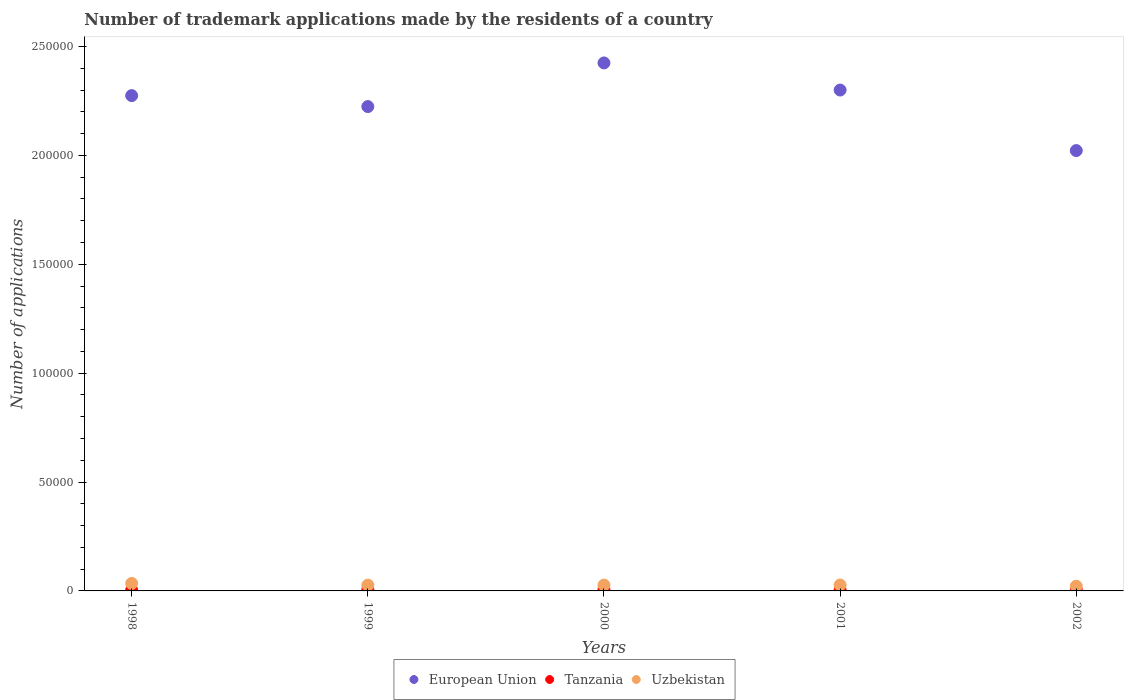How many different coloured dotlines are there?
Ensure brevity in your answer.  3. What is the number of trademark applications made by the residents in Uzbekistan in 1998?
Your response must be concise. 3441. Across all years, what is the maximum number of trademark applications made by the residents in European Union?
Offer a very short reply. 2.42e+05. Across all years, what is the minimum number of trademark applications made by the residents in Tanzania?
Provide a succinct answer. 412. In which year was the number of trademark applications made by the residents in Tanzania maximum?
Your answer should be very brief. 1999. In which year was the number of trademark applications made by the residents in Uzbekistan minimum?
Offer a very short reply. 2002. What is the total number of trademark applications made by the residents in Uzbekistan in the graph?
Ensure brevity in your answer.  1.37e+04. What is the difference between the number of trademark applications made by the residents in European Union in 2001 and that in 2002?
Your answer should be very brief. 2.78e+04. What is the difference between the number of trademark applications made by the residents in European Union in 2002 and the number of trademark applications made by the residents in Uzbekistan in 2000?
Your answer should be very brief. 2.00e+05. What is the average number of trademark applications made by the residents in Tanzania per year?
Offer a terse response. 505.2. In the year 1998, what is the difference between the number of trademark applications made by the residents in Tanzania and number of trademark applications made by the residents in Uzbekistan?
Provide a succinct answer. -3029. In how many years, is the number of trademark applications made by the residents in Uzbekistan greater than 210000?
Offer a very short reply. 0. What is the ratio of the number of trademark applications made by the residents in Uzbekistan in 1999 to that in 2001?
Offer a very short reply. 0.98. Is the difference between the number of trademark applications made by the residents in Tanzania in 1999 and 2001 greater than the difference between the number of trademark applications made by the residents in Uzbekistan in 1999 and 2001?
Make the answer very short. Yes. What is the difference between the highest and the second highest number of trademark applications made by the residents in European Union?
Your answer should be very brief. 1.25e+04. What is the difference between the highest and the lowest number of trademark applications made by the residents in European Union?
Provide a succinct answer. 4.03e+04. How many dotlines are there?
Your answer should be very brief. 3. Are the values on the major ticks of Y-axis written in scientific E-notation?
Offer a very short reply. No. Does the graph contain grids?
Keep it short and to the point. No. Where does the legend appear in the graph?
Provide a succinct answer. Bottom center. How are the legend labels stacked?
Your response must be concise. Horizontal. What is the title of the graph?
Your answer should be compact. Number of trademark applications made by the residents of a country. What is the label or title of the Y-axis?
Offer a very short reply. Number of applications. What is the Number of applications of European Union in 1998?
Ensure brevity in your answer.  2.27e+05. What is the Number of applications in Tanzania in 1998?
Your answer should be very brief. 412. What is the Number of applications of Uzbekistan in 1998?
Keep it short and to the point. 3441. What is the Number of applications in European Union in 1999?
Ensure brevity in your answer.  2.22e+05. What is the Number of applications of Tanzania in 1999?
Offer a very short reply. 620. What is the Number of applications in Uzbekistan in 1999?
Make the answer very short. 2662. What is the Number of applications in European Union in 2000?
Give a very brief answer. 2.42e+05. What is the Number of applications of Tanzania in 2000?
Your response must be concise. 620. What is the Number of applications in Uzbekistan in 2000?
Give a very brief answer. 2686. What is the Number of applications in European Union in 2001?
Give a very brief answer. 2.30e+05. What is the Number of applications of Tanzania in 2001?
Your answer should be compact. 459. What is the Number of applications in Uzbekistan in 2001?
Keep it short and to the point. 2723. What is the Number of applications of European Union in 2002?
Your answer should be compact. 2.02e+05. What is the Number of applications in Tanzania in 2002?
Your answer should be very brief. 415. What is the Number of applications of Uzbekistan in 2002?
Your response must be concise. 2166. Across all years, what is the maximum Number of applications of European Union?
Provide a succinct answer. 2.42e+05. Across all years, what is the maximum Number of applications of Tanzania?
Ensure brevity in your answer.  620. Across all years, what is the maximum Number of applications in Uzbekistan?
Your answer should be very brief. 3441. Across all years, what is the minimum Number of applications of European Union?
Your answer should be very brief. 2.02e+05. Across all years, what is the minimum Number of applications of Tanzania?
Make the answer very short. 412. Across all years, what is the minimum Number of applications in Uzbekistan?
Provide a short and direct response. 2166. What is the total Number of applications of European Union in the graph?
Keep it short and to the point. 1.12e+06. What is the total Number of applications of Tanzania in the graph?
Your answer should be compact. 2526. What is the total Number of applications of Uzbekistan in the graph?
Ensure brevity in your answer.  1.37e+04. What is the difference between the Number of applications of European Union in 1998 and that in 1999?
Ensure brevity in your answer.  5029. What is the difference between the Number of applications in Tanzania in 1998 and that in 1999?
Keep it short and to the point. -208. What is the difference between the Number of applications in Uzbekistan in 1998 and that in 1999?
Keep it short and to the point. 779. What is the difference between the Number of applications in European Union in 1998 and that in 2000?
Provide a short and direct response. -1.50e+04. What is the difference between the Number of applications of Tanzania in 1998 and that in 2000?
Your answer should be very brief. -208. What is the difference between the Number of applications of Uzbekistan in 1998 and that in 2000?
Your answer should be compact. 755. What is the difference between the Number of applications of European Union in 1998 and that in 2001?
Ensure brevity in your answer.  -2562. What is the difference between the Number of applications in Tanzania in 1998 and that in 2001?
Your answer should be very brief. -47. What is the difference between the Number of applications in Uzbekistan in 1998 and that in 2001?
Your answer should be very brief. 718. What is the difference between the Number of applications in European Union in 1998 and that in 2002?
Provide a succinct answer. 2.52e+04. What is the difference between the Number of applications of Tanzania in 1998 and that in 2002?
Your answer should be very brief. -3. What is the difference between the Number of applications of Uzbekistan in 1998 and that in 2002?
Offer a terse response. 1275. What is the difference between the Number of applications of European Union in 1999 and that in 2000?
Make the answer very short. -2.00e+04. What is the difference between the Number of applications of Uzbekistan in 1999 and that in 2000?
Offer a terse response. -24. What is the difference between the Number of applications in European Union in 1999 and that in 2001?
Provide a succinct answer. -7591. What is the difference between the Number of applications in Tanzania in 1999 and that in 2001?
Offer a very short reply. 161. What is the difference between the Number of applications of Uzbekistan in 1999 and that in 2001?
Give a very brief answer. -61. What is the difference between the Number of applications in European Union in 1999 and that in 2002?
Offer a terse response. 2.02e+04. What is the difference between the Number of applications in Tanzania in 1999 and that in 2002?
Make the answer very short. 205. What is the difference between the Number of applications of Uzbekistan in 1999 and that in 2002?
Ensure brevity in your answer.  496. What is the difference between the Number of applications in European Union in 2000 and that in 2001?
Provide a short and direct response. 1.25e+04. What is the difference between the Number of applications of Tanzania in 2000 and that in 2001?
Offer a very short reply. 161. What is the difference between the Number of applications in Uzbekistan in 2000 and that in 2001?
Your answer should be compact. -37. What is the difference between the Number of applications of European Union in 2000 and that in 2002?
Make the answer very short. 4.03e+04. What is the difference between the Number of applications of Tanzania in 2000 and that in 2002?
Make the answer very short. 205. What is the difference between the Number of applications in Uzbekistan in 2000 and that in 2002?
Your answer should be compact. 520. What is the difference between the Number of applications in European Union in 2001 and that in 2002?
Provide a succinct answer. 2.78e+04. What is the difference between the Number of applications in Tanzania in 2001 and that in 2002?
Your answer should be very brief. 44. What is the difference between the Number of applications of Uzbekistan in 2001 and that in 2002?
Offer a terse response. 557. What is the difference between the Number of applications in European Union in 1998 and the Number of applications in Tanzania in 1999?
Provide a succinct answer. 2.27e+05. What is the difference between the Number of applications in European Union in 1998 and the Number of applications in Uzbekistan in 1999?
Offer a terse response. 2.25e+05. What is the difference between the Number of applications of Tanzania in 1998 and the Number of applications of Uzbekistan in 1999?
Make the answer very short. -2250. What is the difference between the Number of applications in European Union in 1998 and the Number of applications in Tanzania in 2000?
Ensure brevity in your answer.  2.27e+05. What is the difference between the Number of applications of European Union in 1998 and the Number of applications of Uzbekistan in 2000?
Your response must be concise. 2.25e+05. What is the difference between the Number of applications of Tanzania in 1998 and the Number of applications of Uzbekistan in 2000?
Your response must be concise. -2274. What is the difference between the Number of applications of European Union in 1998 and the Number of applications of Tanzania in 2001?
Offer a terse response. 2.27e+05. What is the difference between the Number of applications of European Union in 1998 and the Number of applications of Uzbekistan in 2001?
Keep it short and to the point. 2.25e+05. What is the difference between the Number of applications in Tanzania in 1998 and the Number of applications in Uzbekistan in 2001?
Your answer should be very brief. -2311. What is the difference between the Number of applications in European Union in 1998 and the Number of applications in Tanzania in 2002?
Your answer should be very brief. 2.27e+05. What is the difference between the Number of applications in European Union in 1998 and the Number of applications in Uzbekistan in 2002?
Give a very brief answer. 2.25e+05. What is the difference between the Number of applications in Tanzania in 1998 and the Number of applications in Uzbekistan in 2002?
Your response must be concise. -1754. What is the difference between the Number of applications in European Union in 1999 and the Number of applications in Tanzania in 2000?
Ensure brevity in your answer.  2.22e+05. What is the difference between the Number of applications in European Union in 1999 and the Number of applications in Uzbekistan in 2000?
Your response must be concise. 2.20e+05. What is the difference between the Number of applications of Tanzania in 1999 and the Number of applications of Uzbekistan in 2000?
Make the answer very short. -2066. What is the difference between the Number of applications of European Union in 1999 and the Number of applications of Tanzania in 2001?
Offer a very short reply. 2.22e+05. What is the difference between the Number of applications in European Union in 1999 and the Number of applications in Uzbekistan in 2001?
Provide a short and direct response. 2.20e+05. What is the difference between the Number of applications of Tanzania in 1999 and the Number of applications of Uzbekistan in 2001?
Provide a succinct answer. -2103. What is the difference between the Number of applications of European Union in 1999 and the Number of applications of Tanzania in 2002?
Your response must be concise. 2.22e+05. What is the difference between the Number of applications of European Union in 1999 and the Number of applications of Uzbekistan in 2002?
Give a very brief answer. 2.20e+05. What is the difference between the Number of applications in Tanzania in 1999 and the Number of applications in Uzbekistan in 2002?
Your answer should be compact. -1546. What is the difference between the Number of applications of European Union in 2000 and the Number of applications of Tanzania in 2001?
Offer a terse response. 2.42e+05. What is the difference between the Number of applications of European Union in 2000 and the Number of applications of Uzbekistan in 2001?
Make the answer very short. 2.40e+05. What is the difference between the Number of applications of Tanzania in 2000 and the Number of applications of Uzbekistan in 2001?
Make the answer very short. -2103. What is the difference between the Number of applications of European Union in 2000 and the Number of applications of Tanzania in 2002?
Offer a terse response. 2.42e+05. What is the difference between the Number of applications of European Union in 2000 and the Number of applications of Uzbekistan in 2002?
Offer a terse response. 2.40e+05. What is the difference between the Number of applications in Tanzania in 2000 and the Number of applications in Uzbekistan in 2002?
Your answer should be very brief. -1546. What is the difference between the Number of applications in European Union in 2001 and the Number of applications in Tanzania in 2002?
Your response must be concise. 2.30e+05. What is the difference between the Number of applications of European Union in 2001 and the Number of applications of Uzbekistan in 2002?
Offer a terse response. 2.28e+05. What is the difference between the Number of applications in Tanzania in 2001 and the Number of applications in Uzbekistan in 2002?
Your answer should be compact. -1707. What is the average Number of applications in European Union per year?
Keep it short and to the point. 2.25e+05. What is the average Number of applications in Tanzania per year?
Give a very brief answer. 505.2. What is the average Number of applications of Uzbekistan per year?
Your response must be concise. 2735.6. In the year 1998, what is the difference between the Number of applications of European Union and Number of applications of Tanzania?
Keep it short and to the point. 2.27e+05. In the year 1998, what is the difference between the Number of applications of European Union and Number of applications of Uzbekistan?
Your answer should be compact. 2.24e+05. In the year 1998, what is the difference between the Number of applications of Tanzania and Number of applications of Uzbekistan?
Provide a short and direct response. -3029. In the year 1999, what is the difference between the Number of applications of European Union and Number of applications of Tanzania?
Give a very brief answer. 2.22e+05. In the year 1999, what is the difference between the Number of applications in European Union and Number of applications in Uzbekistan?
Your response must be concise. 2.20e+05. In the year 1999, what is the difference between the Number of applications of Tanzania and Number of applications of Uzbekistan?
Keep it short and to the point. -2042. In the year 2000, what is the difference between the Number of applications in European Union and Number of applications in Tanzania?
Give a very brief answer. 2.42e+05. In the year 2000, what is the difference between the Number of applications in European Union and Number of applications in Uzbekistan?
Offer a terse response. 2.40e+05. In the year 2000, what is the difference between the Number of applications in Tanzania and Number of applications in Uzbekistan?
Your answer should be compact. -2066. In the year 2001, what is the difference between the Number of applications of European Union and Number of applications of Tanzania?
Your answer should be very brief. 2.30e+05. In the year 2001, what is the difference between the Number of applications in European Union and Number of applications in Uzbekistan?
Make the answer very short. 2.27e+05. In the year 2001, what is the difference between the Number of applications of Tanzania and Number of applications of Uzbekistan?
Offer a very short reply. -2264. In the year 2002, what is the difference between the Number of applications in European Union and Number of applications in Tanzania?
Provide a succinct answer. 2.02e+05. In the year 2002, what is the difference between the Number of applications in European Union and Number of applications in Uzbekistan?
Give a very brief answer. 2.00e+05. In the year 2002, what is the difference between the Number of applications in Tanzania and Number of applications in Uzbekistan?
Give a very brief answer. -1751. What is the ratio of the Number of applications of European Union in 1998 to that in 1999?
Provide a short and direct response. 1.02. What is the ratio of the Number of applications of Tanzania in 1998 to that in 1999?
Keep it short and to the point. 0.66. What is the ratio of the Number of applications in Uzbekistan in 1998 to that in 1999?
Provide a short and direct response. 1.29. What is the ratio of the Number of applications in European Union in 1998 to that in 2000?
Make the answer very short. 0.94. What is the ratio of the Number of applications of Tanzania in 1998 to that in 2000?
Your response must be concise. 0.66. What is the ratio of the Number of applications in Uzbekistan in 1998 to that in 2000?
Your response must be concise. 1.28. What is the ratio of the Number of applications of European Union in 1998 to that in 2001?
Offer a terse response. 0.99. What is the ratio of the Number of applications in Tanzania in 1998 to that in 2001?
Offer a very short reply. 0.9. What is the ratio of the Number of applications of Uzbekistan in 1998 to that in 2001?
Offer a very short reply. 1.26. What is the ratio of the Number of applications in European Union in 1998 to that in 2002?
Keep it short and to the point. 1.12. What is the ratio of the Number of applications of Tanzania in 1998 to that in 2002?
Offer a very short reply. 0.99. What is the ratio of the Number of applications of Uzbekistan in 1998 to that in 2002?
Make the answer very short. 1.59. What is the ratio of the Number of applications in European Union in 1999 to that in 2000?
Your response must be concise. 0.92. What is the ratio of the Number of applications of Tanzania in 1999 to that in 2000?
Provide a short and direct response. 1. What is the ratio of the Number of applications in Tanzania in 1999 to that in 2001?
Offer a very short reply. 1.35. What is the ratio of the Number of applications in Uzbekistan in 1999 to that in 2001?
Provide a short and direct response. 0.98. What is the ratio of the Number of applications of European Union in 1999 to that in 2002?
Give a very brief answer. 1.1. What is the ratio of the Number of applications of Tanzania in 1999 to that in 2002?
Give a very brief answer. 1.49. What is the ratio of the Number of applications in Uzbekistan in 1999 to that in 2002?
Ensure brevity in your answer.  1.23. What is the ratio of the Number of applications in European Union in 2000 to that in 2001?
Make the answer very short. 1.05. What is the ratio of the Number of applications in Tanzania in 2000 to that in 2001?
Make the answer very short. 1.35. What is the ratio of the Number of applications of Uzbekistan in 2000 to that in 2001?
Your answer should be compact. 0.99. What is the ratio of the Number of applications in European Union in 2000 to that in 2002?
Provide a short and direct response. 1.2. What is the ratio of the Number of applications in Tanzania in 2000 to that in 2002?
Offer a very short reply. 1.49. What is the ratio of the Number of applications in Uzbekistan in 2000 to that in 2002?
Keep it short and to the point. 1.24. What is the ratio of the Number of applications of European Union in 2001 to that in 2002?
Your answer should be compact. 1.14. What is the ratio of the Number of applications of Tanzania in 2001 to that in 2002?
Your answer should be very brief. 1.11. What is the ratio of the Number of applications of Uzbekistan in 2001 to that in 2002?
Keep it short and to the point. 1.26. What is the difference between the highest and the second highest Number of applications in European Union?
Provide a short and direct response. 1.25e+04. What is the difference between the highest and the second highest Number of applications in Tanzania?
Give a very brief answer. 0. What is the difference between the highest and the second highest Number of applications of Uzbekistan?
Provide a succinct answer. 718. What is the difference between the highest and the lowest Number of applications in European Union?
Your answer should be very brief. 4.03e+04. What is the difference between the highest and the lowest Number of applications in Tanzania?
Offer a terse response. 208. What is the difference between the highest and the lowest Number of applications in Uzbekistan?
Ensure brevity in your answer.  1275. 